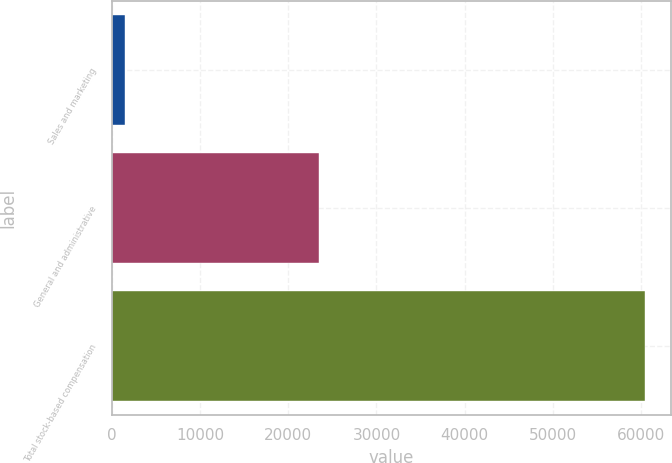Convert chart to OTSL. <chart><loc_0><loc_0><loc_500><loc_500><bar_chart><fcel>Sales and marketing<fcel>General and administrative<fcel>Total stock-based compensation<nl><fcel>1553<fcel>23452<fcel>60384<nl></chart> 